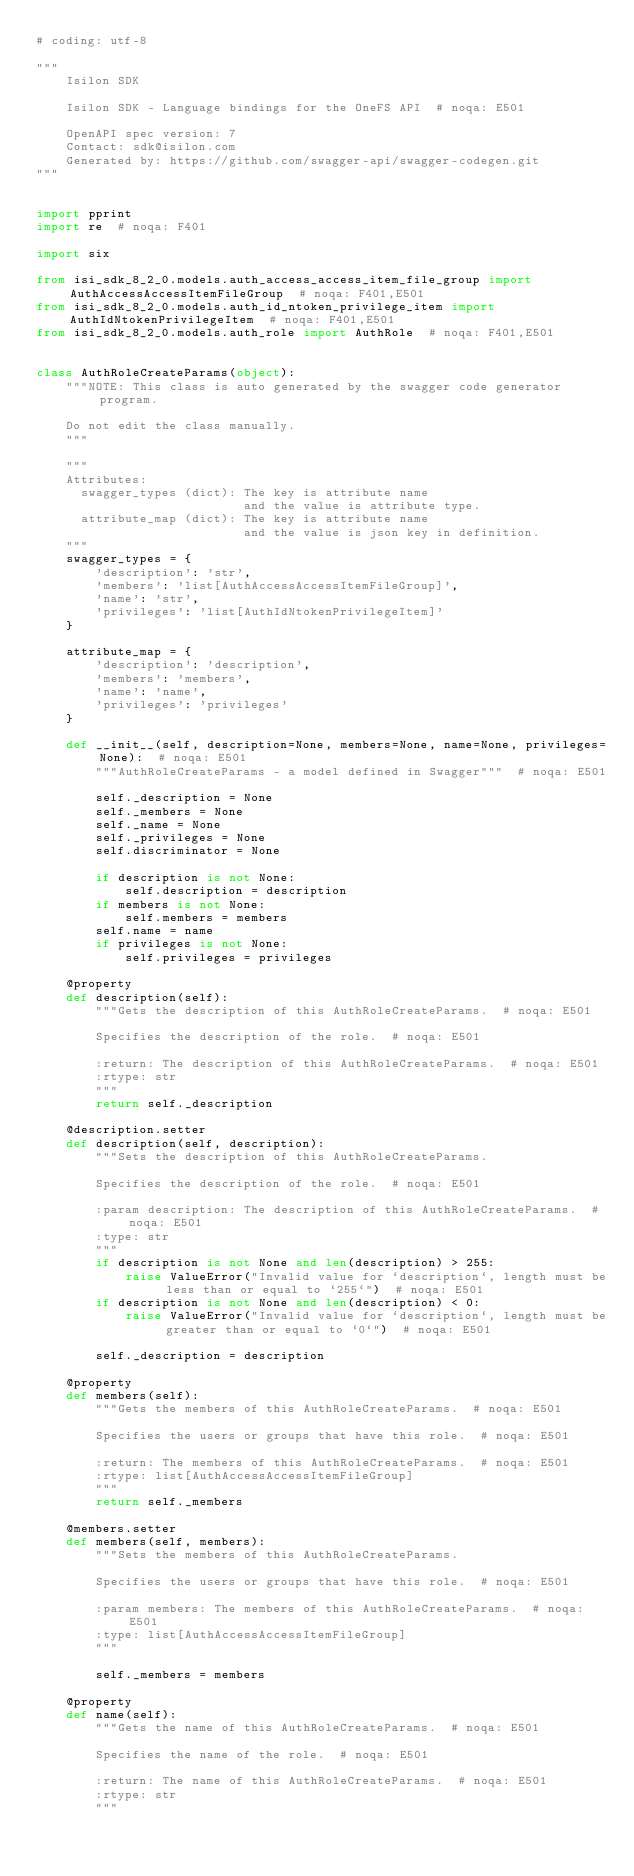<code> <loc_0><loc_0><loc_500><loc_500><_Python_># coding: utf-8

"""
    Isilon SDK

    Isilon SDK - Language bindings for the OneFS API  # noqa: E501

    OpenAPI spec version: 7
    Contact: sdk@isilon.com
    Generated by: https://github.com/swagger-api/swagger-codegen.git
"""


import pprint
import re  # noqa: F401

import six

from isi_sdk_8_2_0.models.auth_access_access_item_file_group import AuthAccessAccessItemFileGroup  # noqa: F401,E501
from isi_sdk_8_2_0.models.auth_id_ntoken_privilege_item import AuthIdNtokenPrivilegeItem  # noqa: F401,E501
from isi_sdk_8_2_0.models.auth_role import AuthRole  # noqa: F401,E501


class AuthRoleCreateParams(object):
    """NOTE: This class is auto generated by the swagger code generator program.

    Do not edit the class manually.
    """

    """
    Attributes:
      swagger_types (dict): The key is attribute name
                            and the value is attribute type.
      attribute_map (dict): The key is attribute name
                            and the value is json key in definition.
    """
    swagger_types = {
        'description': 'str',
        'members': 'list[AuthAccessAccessItemFileGroup]',
        'name': 'str',
        'privileges': 'list[AuthIdNtokenPrivilegeItem]'
    }

    attribute_map = {
        'description': 'description',
        'members': 'members',
        'name': 'name',
        'privileges': 'privileges'
    }

    def __init__(self, description=None, members=None, name=None, privileges=None):  # noqa: E501
        """AuthRoleCreateParams - a model defined in Swagger"""  # noqa: E501

        self._description = None
        self._members = None
        self._name = None
        self._privileges = None
        self.discriminator = None

        if description is not None:
            self.description = description
        if members is not None:
            self.members = members
        self.name = name
        if privileges is not None:
            self.privileges = privileges

    @property
    def description(self):
        """Gets the description of this AuthRoleCreateParams.  # noqa: E501

        Specifies the description of the role.  # noqa: E501

        :return: The description of this AuthRoleCreateParams.  # noqa: E501
        :rtype: str
        """
        return self._description

    @description.setter
    def description(self, description):
        """Sets the description of this AuthRoleCreateParams.

        Specifies the description of the role.  # noqa: E501

        :param description: The description of this AuthRoleCreateParams.  # noqa: E501
        :type: str
        """
        if description is not None and len(description) > 255:
            raise ValueError("Invalid value for `description`, length must be less than or equal to `255`")  # noqa: E501
        if description is not None and len(description) < 0:
            raise ValueError("Invalid value for `description`, length must be greater than or equal to `0`")  # noqa: E501

        self._description = description

    @property
    def members(self):
        """Gets the members of this AuthRoleCreateParams.  # noqa: E501

        Specifies the users or groups that have this role.  # noqa: E501

        :return: The members of this AuthRoleCreateParams.  # noqa: E501
        :rtype: list[AuthAccessAccessItemFileGroup]
        """
        return self._members

    @members.setter
    def members(self, members):
        """Sets the members of this AuthRoleCreateParams.

        Specifies the users or groups that have this role.  # noqa: E501

        :param members: The members of this AuthRoleCreateParams.  # noqa: E501
        :type: list[AuthAccessAccessItemFileGroup]
        """

        self._members = members

    @property
    def name(self):
        """Gets the name of this AuthRoleCreateParams.  # noqa: E501

        Specifies the name of the role.  # noqa: E501

        :return: The name of this AuthRoleCreateParams.  # noqa: E501
        :rtype: str
        """</code> 